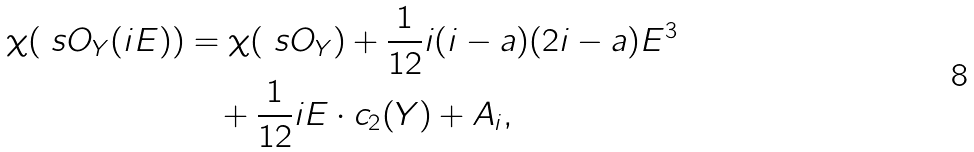<formula> <loc_0><loc_0><loc_500><loc_500>\chi ( \ s O _ { Y } ( i E ) ) & = \chi ( \ s O _ { Y } ) + \frac { 1 } { 1 2 } i ( i - a ) ( 2 i - a ) E ^ { 3 } \\ & \quad + \frac { 1 } { 1 2 } i E \cdot c _ { 2 } ( Y ) + A _ { i } ,</formula> 